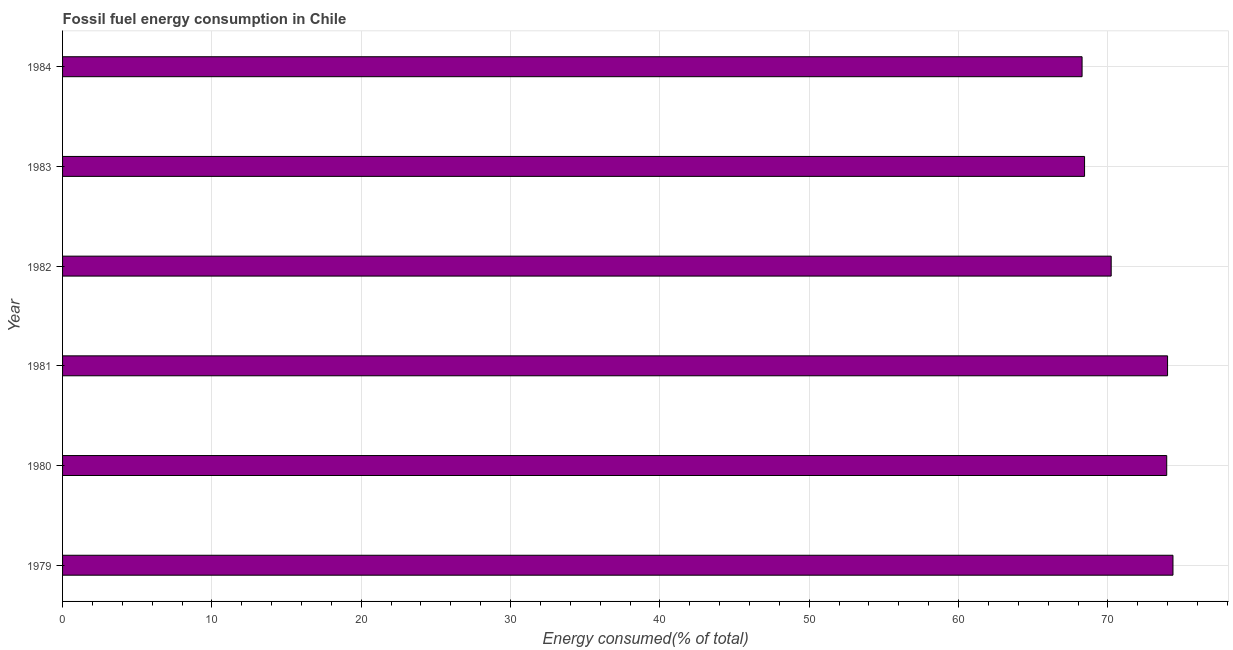What is the title of the graph?
Give a very brief answer. Fossil fuel energy consumption in Chile. What is the label or title of the X-axis?
Offer a very short reply. Energy consumed(% of total). What is the fossil fuel energy consumption in 1979?
Your response must be concise. 74.36. Across all years, what is the maximum fossil fuel energy consumption?
Ensure brevity in your answer.  74.36. Across all years, what is the minimum fossil fuel energy consumption?
Make the answer very short. 68.27. In which year was the fossil fuel energy consumption maximum?
Provide a short and direct response. 1979. What is the sum of the fossil fuel energy consumption?
Provide a succinct answer. 429.22. What is the difference between the fossil fuel energy consumption in 1979 and 1983?
Your answer should be compact. 5.92. What is the average fossil fuel energy consumption per year?
Your answer should be compact. 71.54. What is the median fossil fuel energy consumption?
Your answer should be compact. 72.08. In how many years, is the fossil fuel energy consumption greater than 68 %?
Offer a very short reply. 6. Do a majority of the years between 1984 and 1981 (inclusive) have fossil fuel energy consumption greater than 14 %?
Your answer should be very brief. Yes. What is the ratio of the fossil fuel energy consumption in 1979 to that in 1984?
Provide a succinct answer. 1.09. Is the difference between the fossil fuel energy consumption in 1979 and 1981 greater than the difference between any two years?
Your response must be concise. No. What is the difference between the highest and the second highest fossil fuel energy consumption?
Make the answer very short. 0.36. What is the difference between the highest and the lowest fossil fuel energy consumption?
Your answer should be compact. 6.09. How many bars are there?
Provide a short and direct response. 6. What is the Energy consumed(% of total) of 1979?
Provide a succinct answer. 74.36. What is the Energy consumed(% of total) in 1980?
Ensure brevity in your answer.  73.94. What is the Energy consumed(% of total) of 1981?
Your answer should be very brief. 73.99. What is the Energy consumed(% of total) of 1982?
Your answer should be compact. 70.22. What is the Energy consumed(% of total) of 1983?
Give a very brief answer. 68.44. What is the Energy consumed(% of total) of 1984?
Your response must be concise. 68.27. What is the difference between the Energy consumed(% of total) in 1979 and 1980?
Your response must be concise. 0.42. What is the difference between the Energy consumed(% of total) in 1979 and 1981?
Provide a succinct answer. 0.36. What is the difference between the Energy consumed(% of total) in 1979 and 1982?
Provide a short and direct response. 4.14. What is the difference between the Energy consumed(% of total) in 1979 and 1983?
Provide a succinct answer. 5.92. What is the difference between the Energy consumed(% of total) in 1979 and 1984?
Your answer should be very brief. 6.09. What is the difference between the Energy consumed(% of total) in 1980 and 1981?
Your answer should be compact. -0.06. What is the difference between the Energy consumed(% of total) in 1980 and 1982?
Give a very brief answer. 3.72. What is the difference between the Energy consumed(% of total) in 1980 and 1983?
Make the answer very short. 5.5. What is the difference between the Energy consumed(% of total) in 1980 and 1984?
Ensure brevity in your answer.  5.67. What is the difference between the Energy consumed(% of total) in 1981 and 1982?
Provide a succinct answer. 3.77. What is the difference between the Energy consumed(% of total) in 1981 and 1983?
Keep it short and to the point. 5.56. What is the difference between the Energy consumed(% of total) in 1981 and 1984?
Ensure brevity in your answer.  5.72. What is the difference between the Energy consumed(% of total) in 1982 and 1983?
Ensure brevity in your answer.  1.78. What is the difference between the Energy consumed(% of total) in 1982 and 1984?
Your response must be concise. 1.95. What is the difference between the Energy consumed(% of total) in 1983 and 1984?
Give a very brief answer. 0.17. What is the ratio of the Energy consumed(% of total) in 1979 to that in 1980?
Offer a terse response. 1.01. What is the ratio of the Energy consumed(% of total) in 1979 to that in 1982?
Your answer should be very brief. 1.06. What is the ratio of the Energy consumed(% of total) in 1979 to that in 1983?
Your response must be concise. 1.09. What is the ratio of the Energy consumed(% of total) in 1979 to that in 1984?
Make the answer very short. 1.09. What is the ratio of the Energy consumed(% of total) in 1980 to that in 1982?
Your answer should be compact. 1.05. What is the ratio of the Energy consumed(% of total) in 1980 to that in 1983?
Provide a short and direct response. 1.08. What is the ratio of the Energy consumed(% of total) in 1980 to that in 1984?
Offer a terse response. 1.08. What is the ratio of the Energy consumed(% of total) in 1981 to that in 1982?
Offer a very short reply. 1.05. What is the ratio of the Energy consumed(% of total) in 1981 to that in 1983?
Provide a succinct answer. 1.08. What is the ratio of the Energy consumed(% of total) in 1981 to that in 1984?
Ensure brevity in your answer.  1.08. What is the ratio of the Energy consumed(% of total) in 1982 to that in 1984?
Offer a terse response. 1.03. 